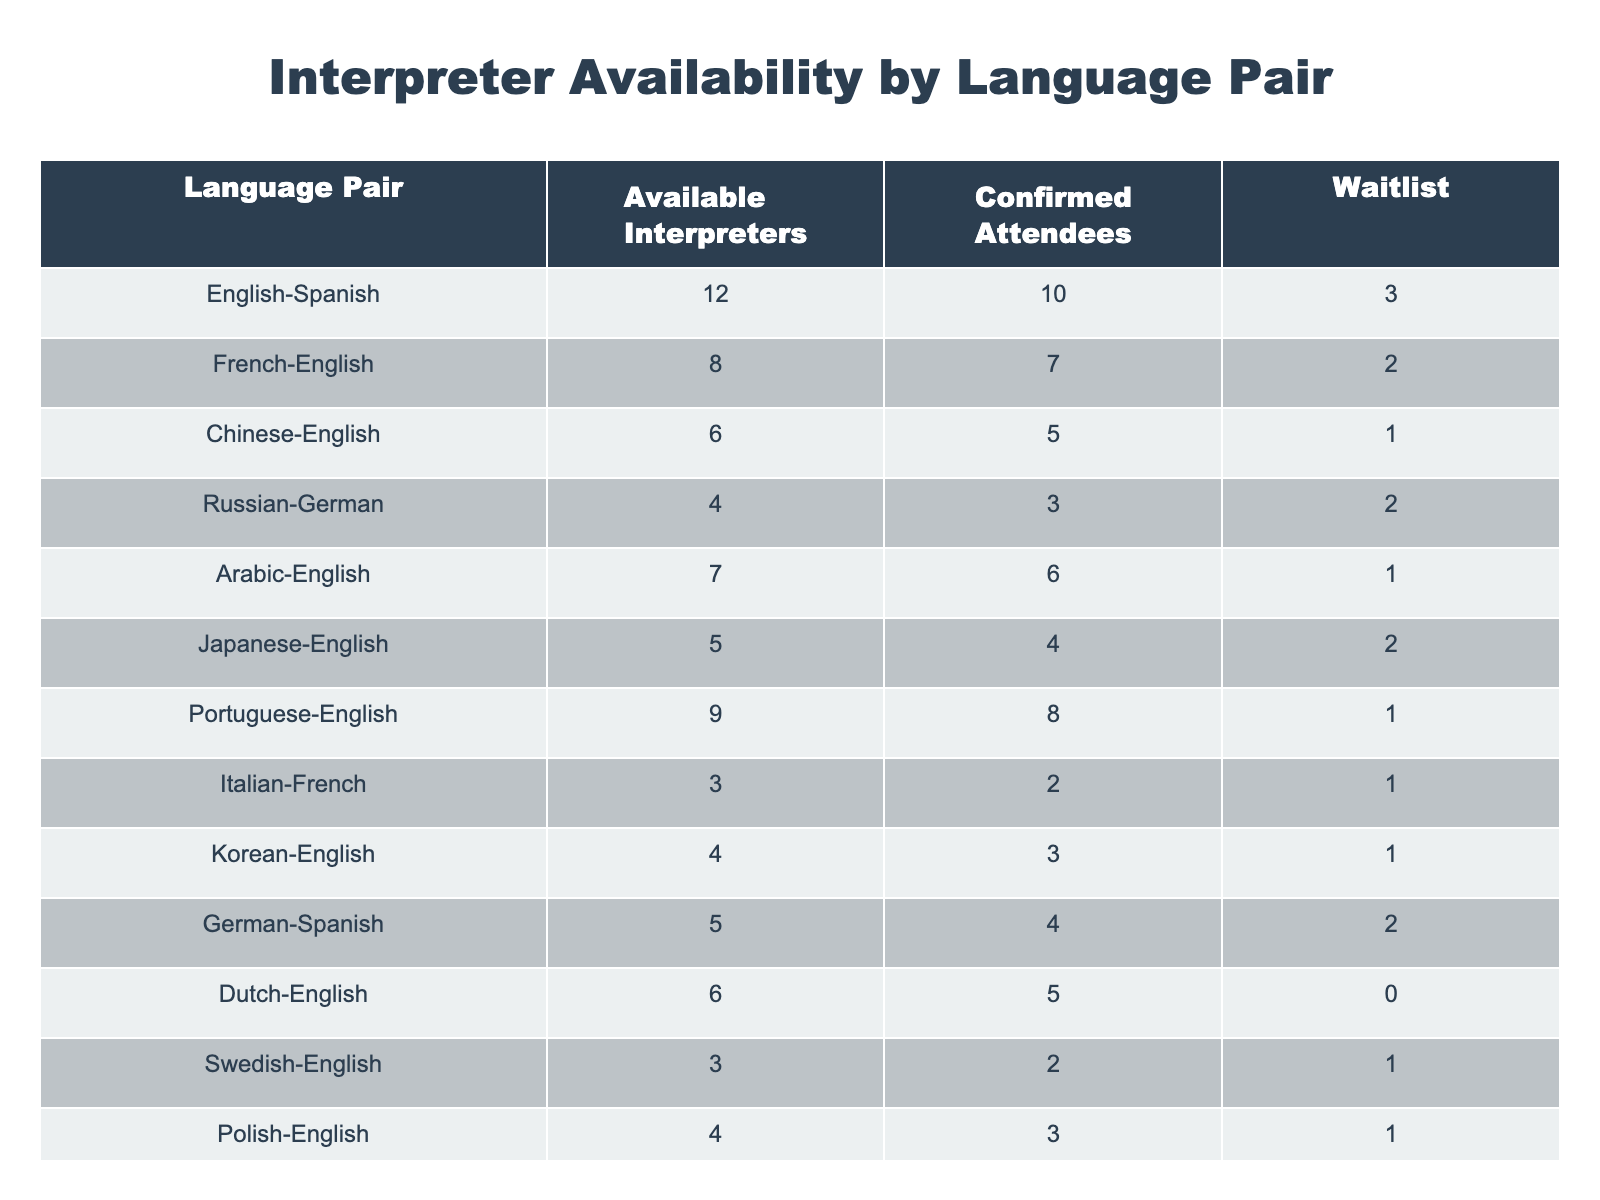What is the total number of available interpreters for English-Spanish? The table indicates that there are 12 available interpreters for the English-Spanish language pair.
Answer: 12 Which language pair has the most confirmed attendees? Looking at the confirmed attendees column, the English-Spanish pair has 10 confirmed attendees, which is the highest number compared to other pairs.
Answer: English-Spanish What is the average number of available interpreters across all language pairs? To find the average, sum up all the available interpreters: (12 + 8 + 6 + 4 + 7 + 5 + 9 + 3 + 4 + 5 + 6 + 3 + 4 + 5 + 2) = 81. There are 15 language pairs, so the average is 81 / 15 = 5.4.
Answer: 5.4 Is there a language pair with no waitlist for interpreters? For the Dutch-English pair, there is a waitlist of 0, indicating there are no pending requests for interpreters for this language pair.
Answer: Yes How many interpreters are available for language pairs that include English? The available interpreters for language pairs including English are: English-Spanish (12), Chinese-English (6), Arabic-English (7), Japanese-English (5), Korean-English (4), Portuguese-English (9), Dutch-English (6), Turkish-English (5). Adding these gives: 12 + 6 + 7 + 5 + 4 + 9 + 6 + 5 = 54.
Answer: 54 Which language pair has the least number of available interpreters? By looking at the available interpreters column, the Greek-French pair has the least with only 2 available interpreters.
Answer: Greek-French Do more attendees exist than available interpreters for any language pair? Upon examining the confirmed attendees and available interpreters for each language pair, it appears that no pair has more confirmed attendees than available interpreters. The highest confirmed attendees (10) for English-Spanish is less than its available interpreters (12).
Answer: No What is the difference between available interpreters and confirmed attendees for the Portuguese-English pair? The number of available interpreters for the Portuguese-English pair is 9, while confirmed attendees are 8. Therefore, the difference is 9 - 8 = 1.
Answer: 1 What is the total number of waitlisted attendees for all language pairs? Summing the waitlist numbers: 3 + 2 + 1 + 2 + 1 + 2 + 1 + 1 + 0 + 1 + 1 + 1 + 1 + 1 = 16.
Answer: 16 